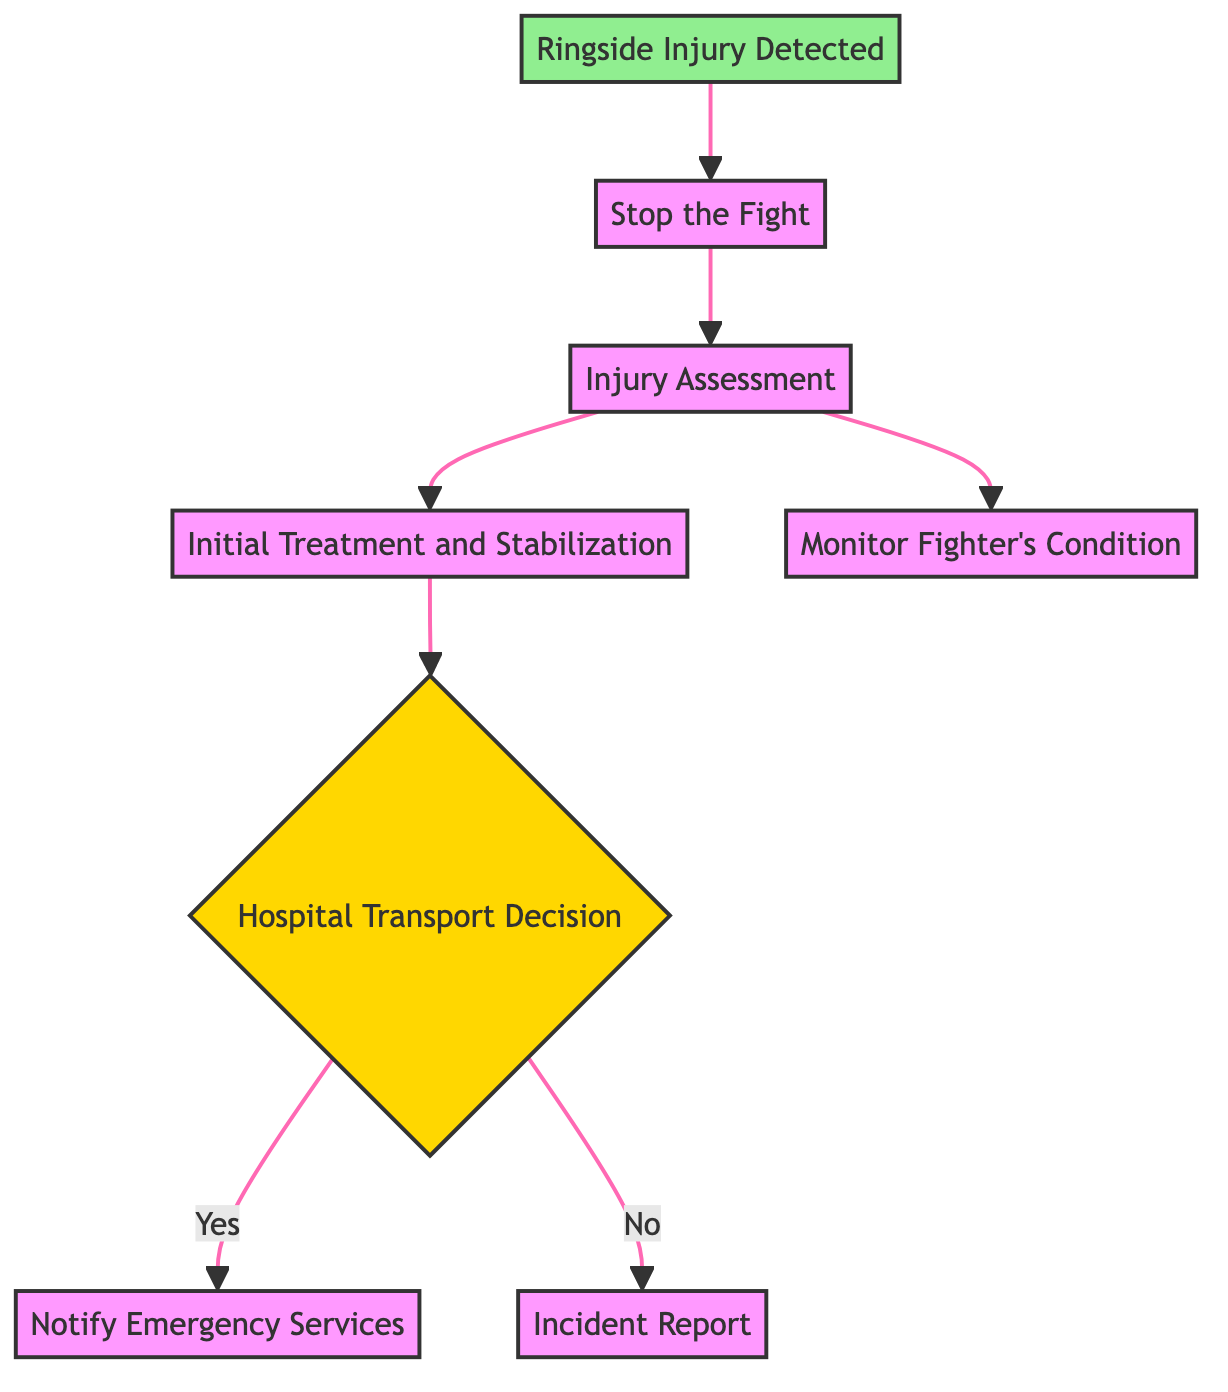What is the first step when a ringside injury is detected? According to the diagram, the first step when a ringside injury is detected is "Stop the Fight". This is the direct process that follows the initial detection of an injury.
Answer: Stop the Fight How many processes are present in the flowchart? The flowchart consists of four process nodes: "Stop the Fight", "Injury Assessment", "Initial Treatment and Stabilization", and "Incident Report". Counting these processes gives a total of four.
Answer: Four What decision must be made after the initial treatment? After providing initial treatment, the decision that must be made is "Hospital Transport Decision". This is crucial to determine the next steps in medical response based on the fighter’s condition.
Answer: Hospital Transport Decision What happens if the hospital transport decision is "yes"? If the hospital transport decision is yes, the next step is to "Notify Emergency Services", which indicates that an ambulance or additional medical support will be called based on the severity of the injury.
Answer: Notify Emergency Services What is the last step to be taken if hospital transport is not required? If hospital transport is not required, the last step is to create an "Incident Report", documenting the injury details and the actions taken during the response.
Answer: Incident Report Which node leads directly to monitoring the fighter's condition? The node that leads directly to monitoring the fighter's condition is "Injury Assessment". After assessing the injury's severity, monitoring the fighter's vital signs becomes the next action.
Answer: Injury Assessment Which process follows the assessment of the injury? The process that follows the assessment of the injury is "Monitor Fighter's Condition". This shows an ongoing assessment is crucial after understanding the injury's severity.
Answer: Monitor Fighter's Condition If an injury is confirmed as severe, what is the immediate action taken? The immediate action taken if an injury is confirmed as severe is to "Stop the Fight". This action prioritizes the safety of the fighter in a critical situation.
Answer: Stop the Fight What is the purpose of the incident report process? The purpose of the incident report process is to document the injury details and the response actions taken, ensuring accurate records for future reference and accountability.
Answer: Document injury details 